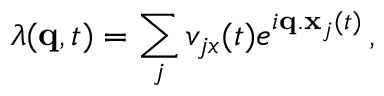Convert formula to latex. <formula><loc_0><loc_0><loc_500><loc_500>\lambda ( q , t ) = \sum _ { j } v _ { j x } ( t ) e ^ { i q . x _ { j } ( t ) } \, ,</formula> 